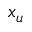Convert formula to latex. <formula><loc_0><loc_0><loc_500><loc_500>x _ { u }</formula> 